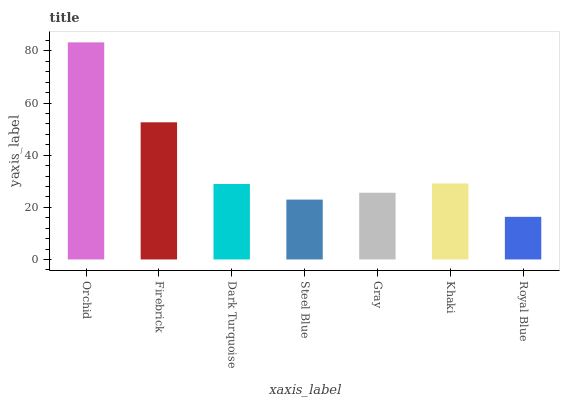Is Royal Blue the minimum?
Answer yes or no. Yes. Is Orchid the maximum?
Answer yes or no. Yes. Is Firebrick the minimum?
Answer yes or no. No. Is Firebrick the maximum?
Answer yes or no. No. Is Orchid greater than Firebrick?
Answer yes or no. Yes. Is Firebrick less than Orchid?
Answer yes or no. Yes. Is Firebrick greater than Orchid?
Answer yes or no. No. Is Orchid less than Firebrick?
Answer yes or no. No. Is Dark Turquoise the high median?
Answer yes or no. Yes. Is Dark Turquoise the low median?
Answer yes or no. Yes. Is Khaki the high median?
Answer yes or no. No. Is Gray the low median?
Answer yes or no. No. 